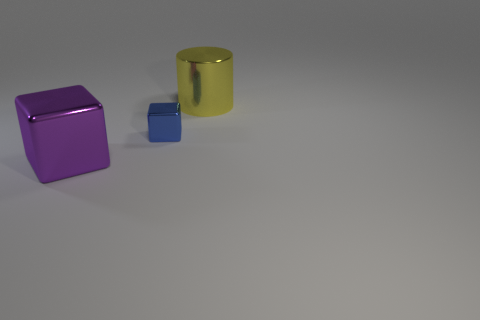How many objects are there, and can you describe their colors? I observe three objects in the image. There's a small blue cube, a larger purple cube, and a big yellow cylindrical block. The blue cube presents a vivid hue, the purple cube has a deeper saturation, and the cylindrical block showcases a shiny, reflective golden-yellow surface. Do the colors of these objects suggest any particular emotional or stylistic theme? The combination of colors can evoke different interpretations. Blue often represents calmness or stability, purple can be associated with luxury or creativity, and gold may suggest wealth or quality. Together, they produce a contrasting palette that is both vibrant and sophisticated. In a stylistic sense, the clear, primary colors and simple shapes are reminiscent of modern or minimalist art. 